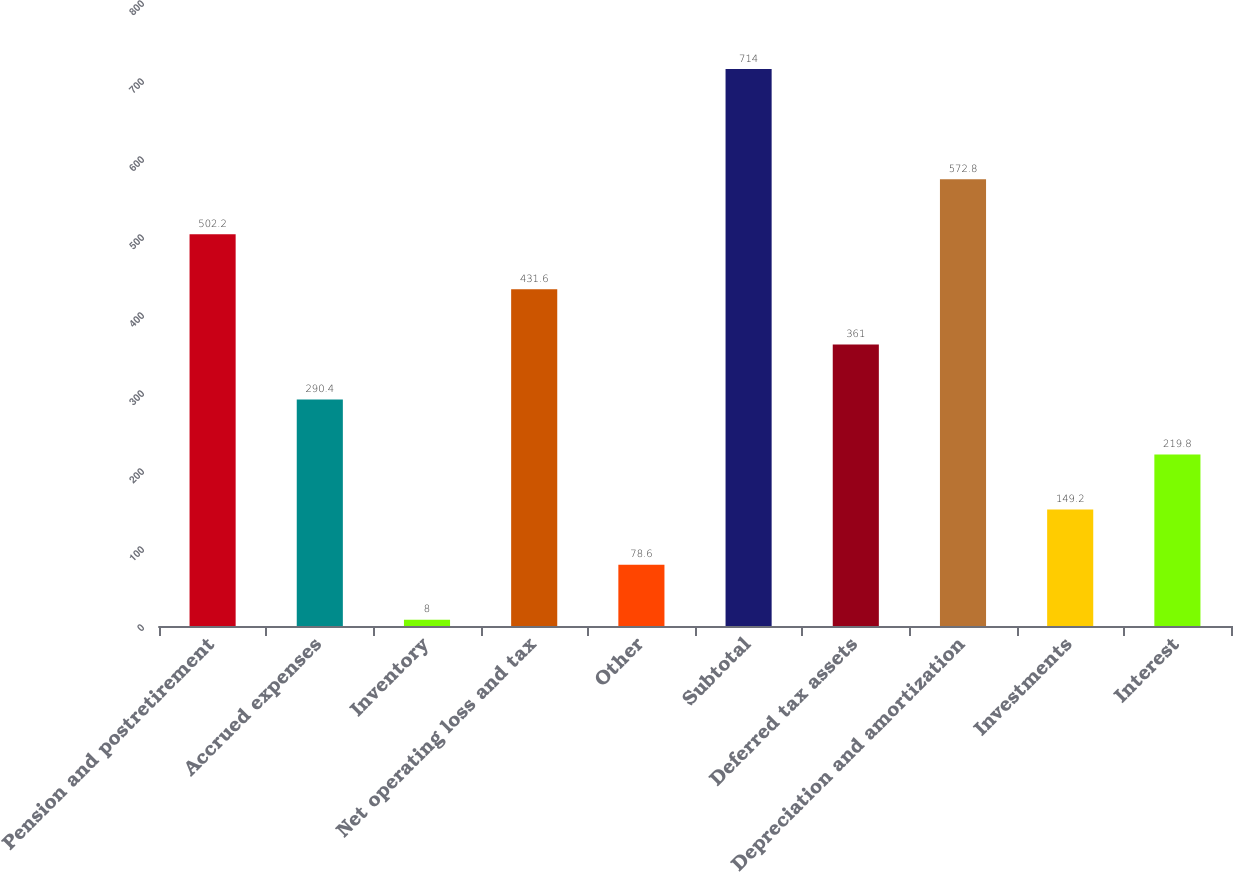<chart> <loc_0><loc_0><loc_500><loc_500><bar_chart><fcel>Pension and postretirement<fcel>Accrued expenses<fcel>Inventory<fcel>Net operating loss and tax<fcel>Other<fcel>Subtotal<fcel>Deferred tax assets<fcel>Depreciation and amortization<fcel>Investments<fcel>Interest<nl><fcel>502.2<fcel>290.4<fcel>8<fcel>431.6<fcel>78.6<fcel>714<fcel>361<fcel>572.8<fcel>149.2<fcel>219.8<nl></chart> 